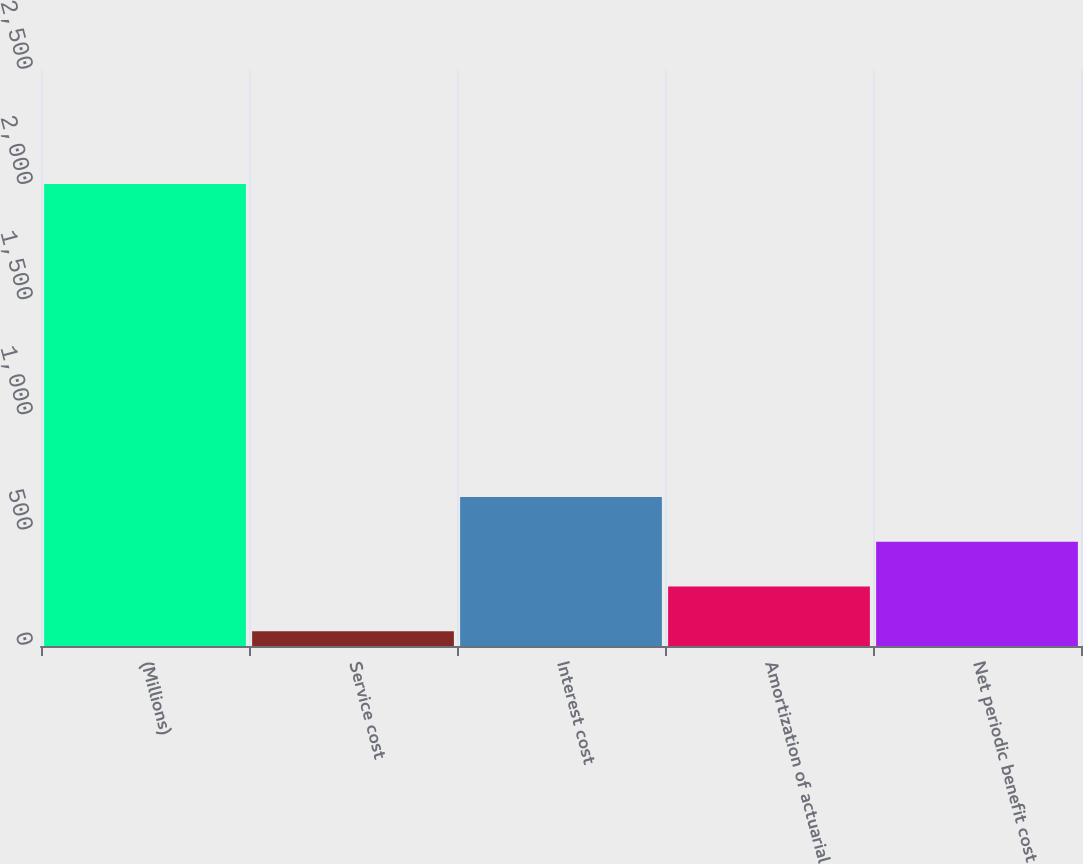Convert chart. <chart><loc_0><loc_0><loc_500><loc_500><bar_chart><fcel>(Millions)<fcel>Service cost<fcel>Interest cost<fcel>Amortization of actuarial<fcel>Net periodic benefit cost<nl><fcel>2005<fcel>64<fcel>646.3<fcel>258.1<fcel>452.2<nl></chart> 